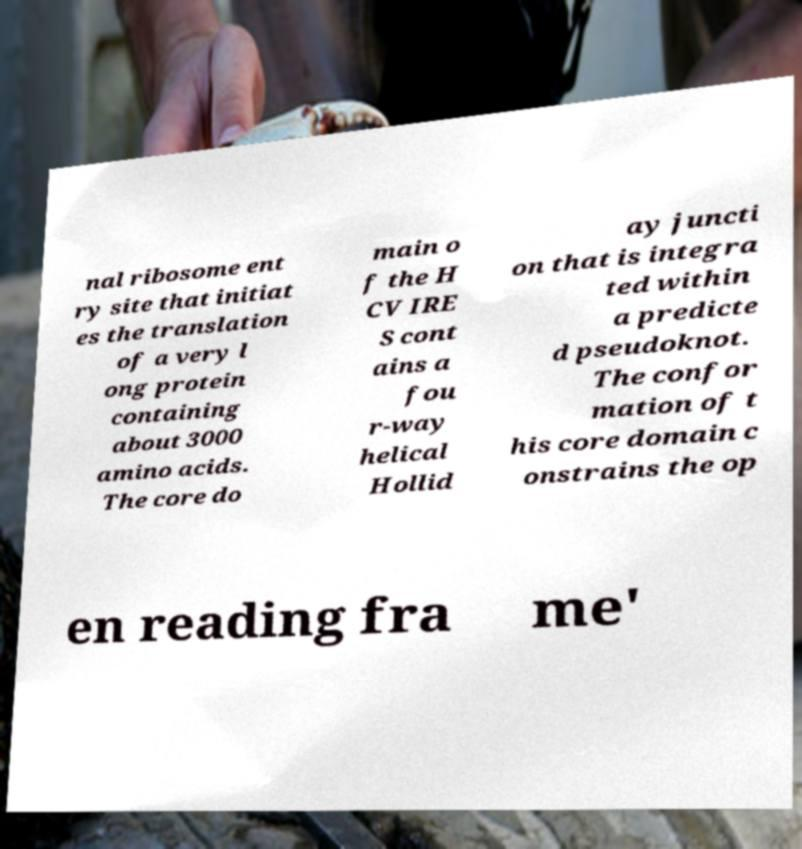Please read and relay the text visible in this image. What does it say? nal ribosome ent ry site that initiat es the translation of a very l ong protein containing about 3000 amino acids. The core do main o f the H CV IRE S cont ains a fou r-way helical Hollid ay juncti on that is integra ted within a predicte d pseudoknot. The confor mation of t his core domain c onstrains the op en reading fra me' 